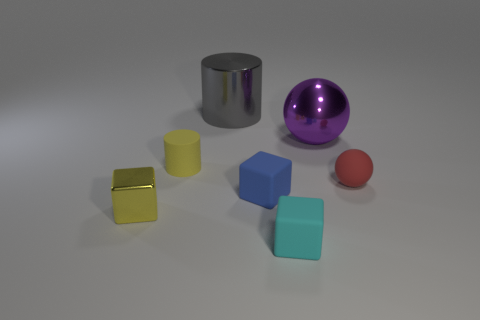Do the tiny cylinder and the shiny block have the same color?
Your answer should be compact. Yes. Are there any matte cylinders of the same color as the metal cube?
Your answer should be compact. Yes. There is another thing that is the same color as the tiny metal object; what is its shape?
Offer a very short reply. Cylinder. What size is the ball that is behind the yellow matte cylinder?
Offer a very short reply. Large. What is the shape of the cyan object that is the same material as the red thing?
Provide a succinct answer. Cube. What number of brown things are cubes or big metallic cylinders?
Ensure brevity in your answer.  0. Are there any small red rubber spheres in front of the yellow metal object?
Keep it short and to the point. No. Is the shape of the large thing to the right of the gray metallic thing the same as the small matte thing to the right of the purple ball?
Your answer should be very brief. Yes. There is a cyan thing that is the same shape as the blue thing; what is its material?
Your response must be concise. Rubber. How many spheres are big purple objects or tiny blue matte things?
Your answer should be compact. 1. 